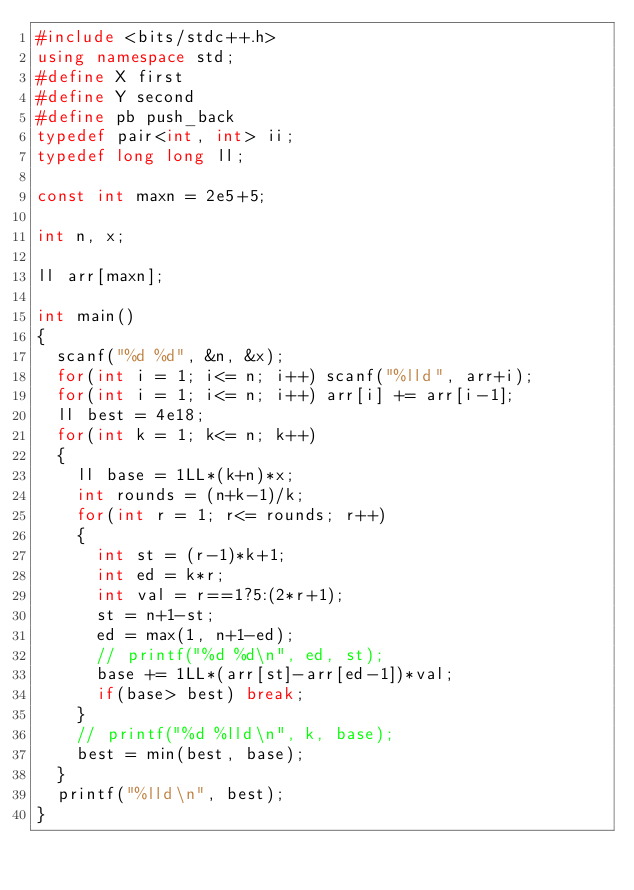Convert code to text. <code><loc_0><loc_0><loc_500><loc_500><_C++_>#include <bits/stdc++.h>
using namespace std;
#define X first
#define Y second
#define pb push_back
typedef pair<int, int> ii;
typedef long long ll;

const int maxn = 2e5+5;

int n, x;

ll arr[maxn];

int main()
{
	scanf("%d %d", &n, &x);
	for(int i = 1; i<= n; i++) scanf("%lld", arr+i);
	for(int i = 1; i<= n; i++) arr[i] += arr[i-1];
	ll best = 4e18;
	for(int k = 1; k<= n; k++)
	{
		ll base = 1LL*(k+n)*x;
		int rounds = (n+k-1)/k;
		for(int r = 1; r<= rounds; r++)
		{
			int st = (r-1)*k+1;
			int ed = k*r;
			int val = r==1?5:(2*r+1);
			st = n+1-st;
			ed = max(1, n+1-ed);
			// printf("%d %d\n", ed, st);
			base += 1LL*(arr[st]-arr[ed-1])*val;
			if(base> best) break;
		}
		// printf("%d %lld\n", k, base);
		best = min(best, base);
	}
	printf("%lld\n", best);
}</code> 